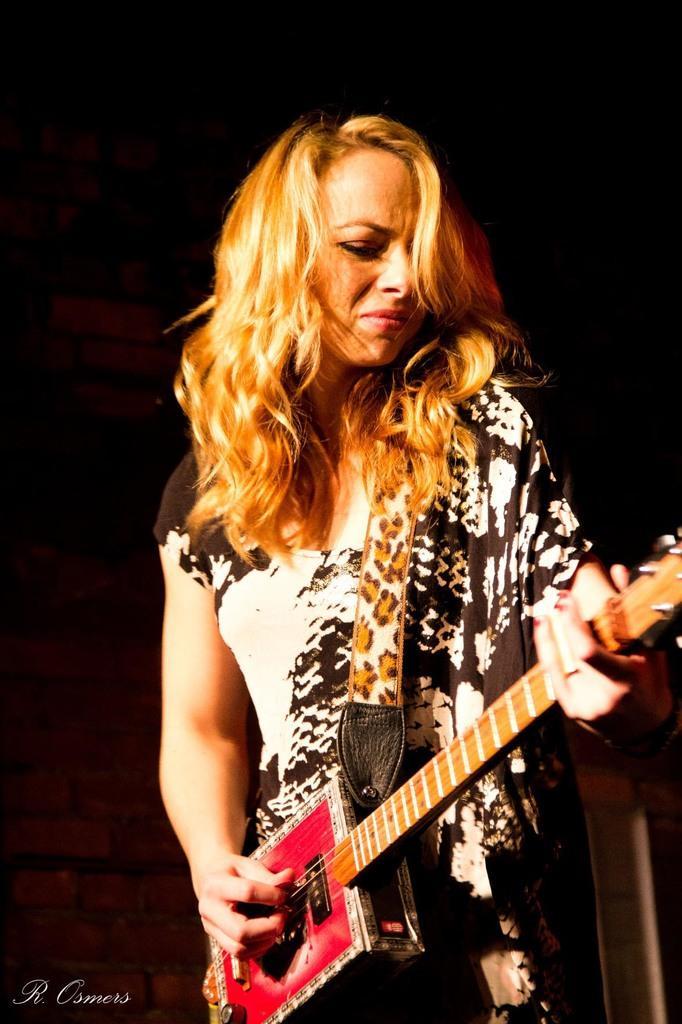Please provide a concise description of this image. In this picture there is a person standing and holding guitar. In this background we can see wall. 